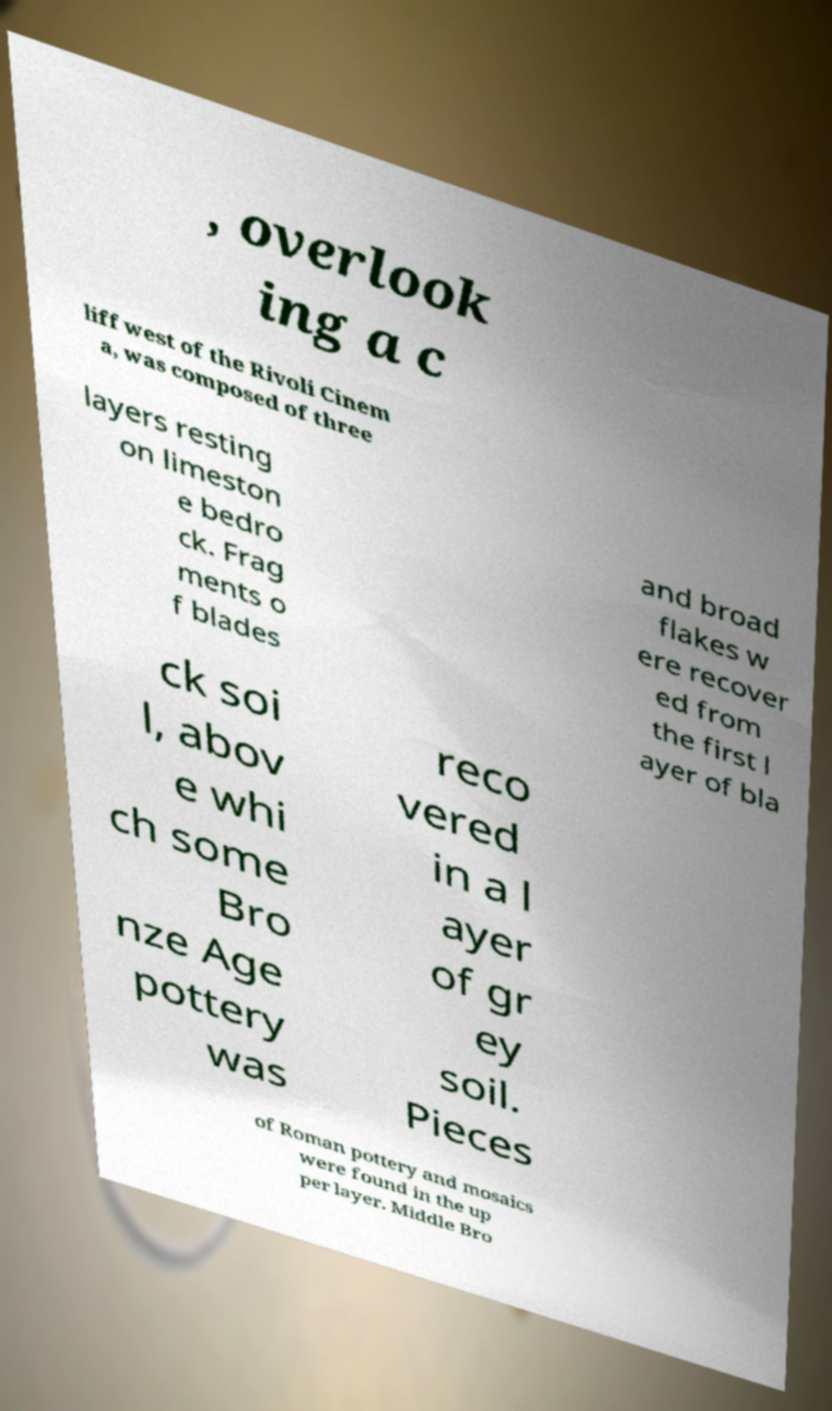For documentation purposes, I need the text within this image transcribed. Could you provide that? , overlook ing a c liff west of the Rivoli Cinem a, was composed of three layers resting on limeston e bedro ck. Frag ments o f blades and broad flakes w ere recover ed from the first l ayer of bla ck soi l, abov e whi ch some Bro nze Age pottery was reco vered in a l ayer of gr ey soil. Pieces of Roman pottery and mosaics were found in the up per layer. Middle Bro 